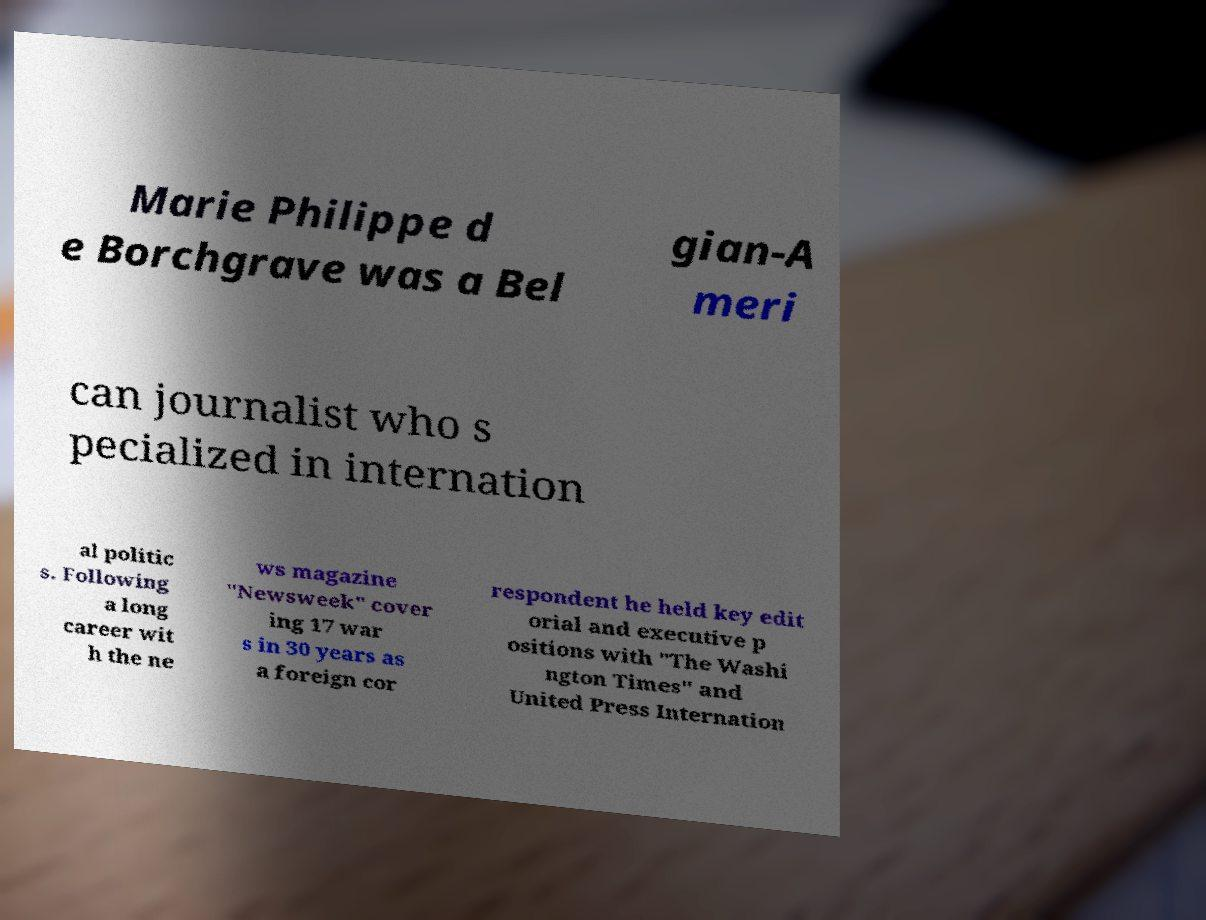Please read and relay the text visible in this image. What does it say? Marie Philippe d e Borchgrave was a Bel gian-A meri can journalist who s pecialized in internation al politic s. Following a long career wit h the ne ws magazine "Newsweek" cover ing 17 war s in 30 years as a foreign cor respondent he held key edit orial and executive p ositions with "The Washi ngton Times" and United Press Internation 